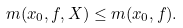Convert formula to latex. <formula><loc_0><loc_0><loc_500><loc_500>m ( x _ { 0 } , f , X ) \leq m ( x _ { 0 } , f ) .</formula> 